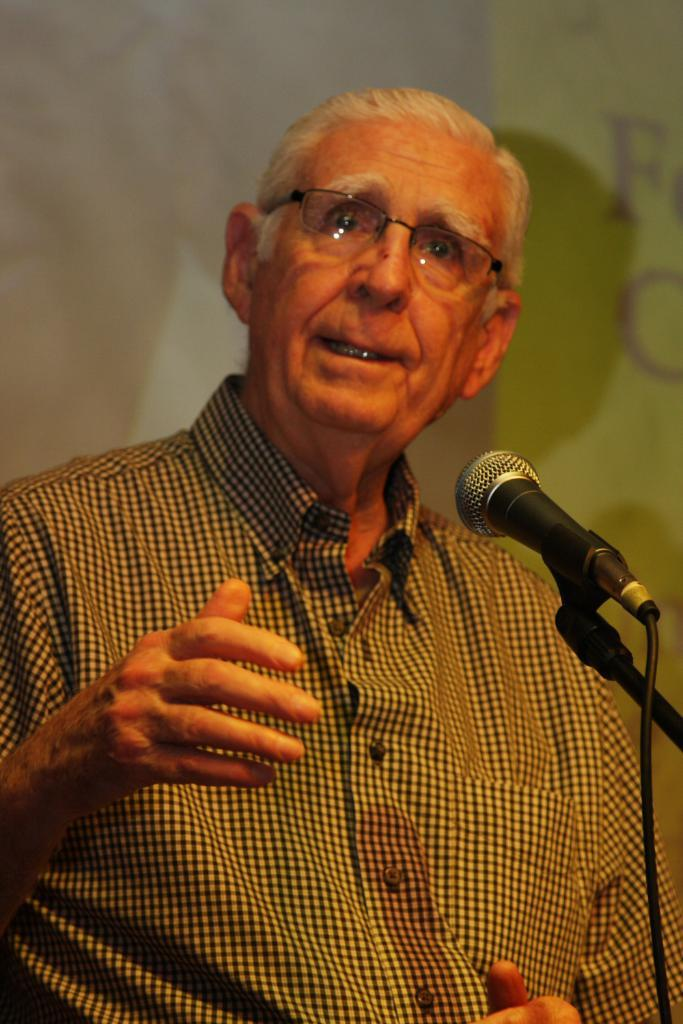Who is present in the image? There is a man in the image. What is the man wearing that is visible in the image? The man is wearing glasses (specs) in the image. What object is present in the image that is used for amplifying sound? There is a microphone (mic) in the image, and it is on a stand. What can be seen in the background of the image? There is a wall in the background of the image. What type of grain is being harvested in the image? There is no grain or harvesting activity present in the image. What belief system is being practiced by the man in the image? The image does not provide any information about the man's belief system. 